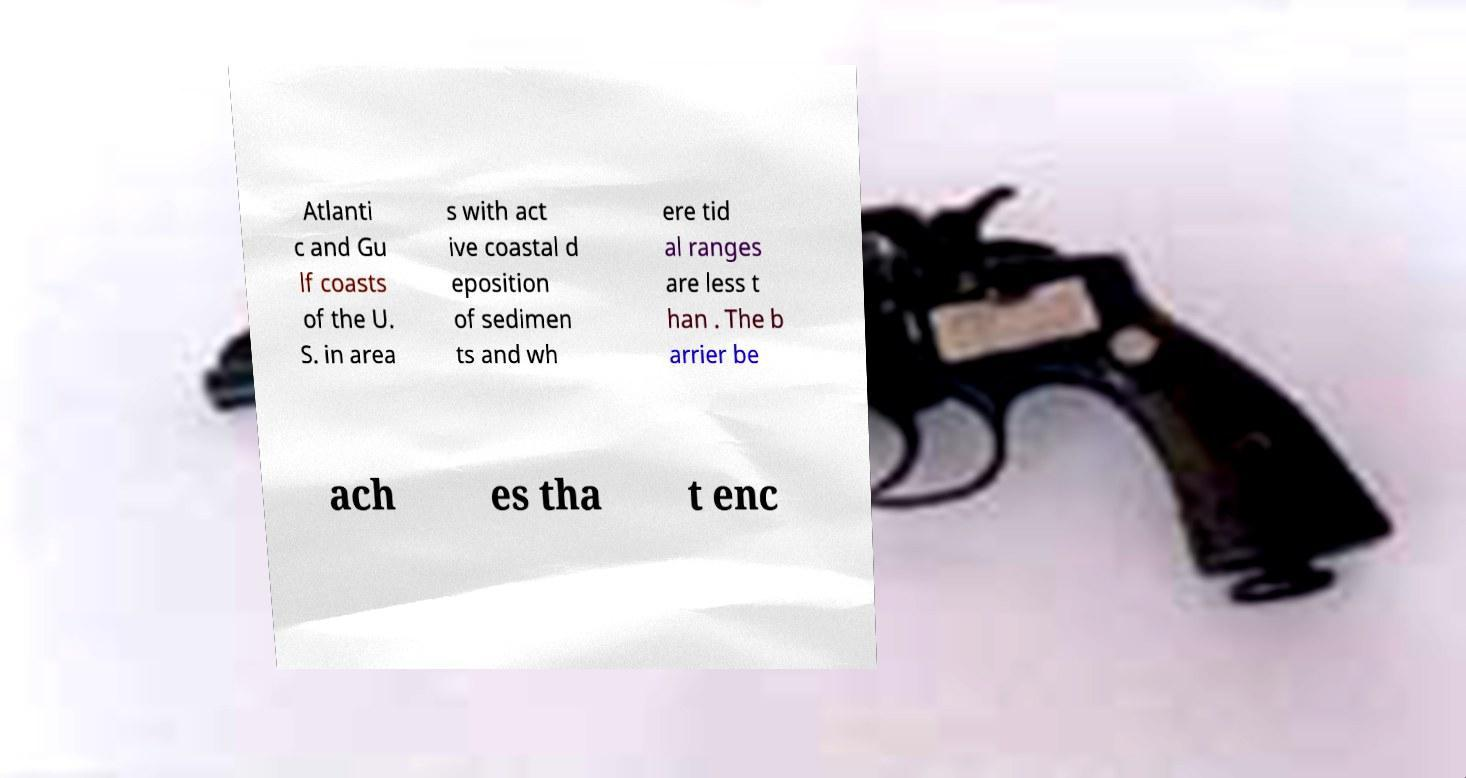Please identify and transcribe the text found in this image. Atlanti c and Gu lf coasts of the U. S. in area s with act ive coastal d eposition of sedimen ts and wh ere tid al ranges are less t han . The b arrier be ach es tha t enc 